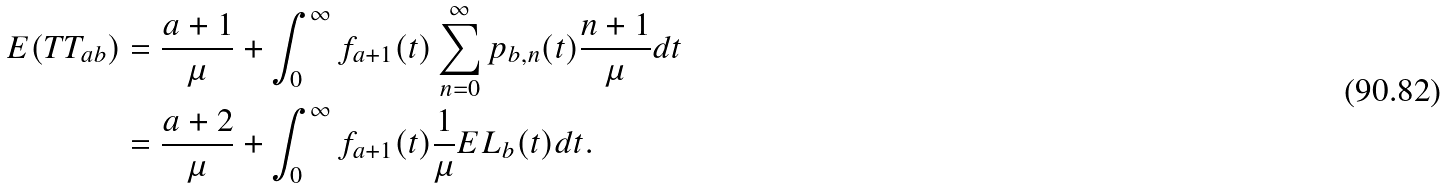Convert formula to latex. <formula><loc_0><loc_0><loc_500><loc_500>E ( T T _ { a b } ) & = \frac { a + 1 } { \mu } + \int _ { 0 } ^ { \infty } { f _ { a + 1 } ( t ) \sum _ { n = 0 } ^ { \infty } p _ { b , n } ( t ) \frac { n + 1 } { \mu } d t } \\ & = \frac { a + 2 } { \mu } + \int _ { 0 } ^ { \infty } { f _ { a + 1 } ( t ) \frac { 1 } { \mu } E L _ { b } ( t ) d t } .</formula> 